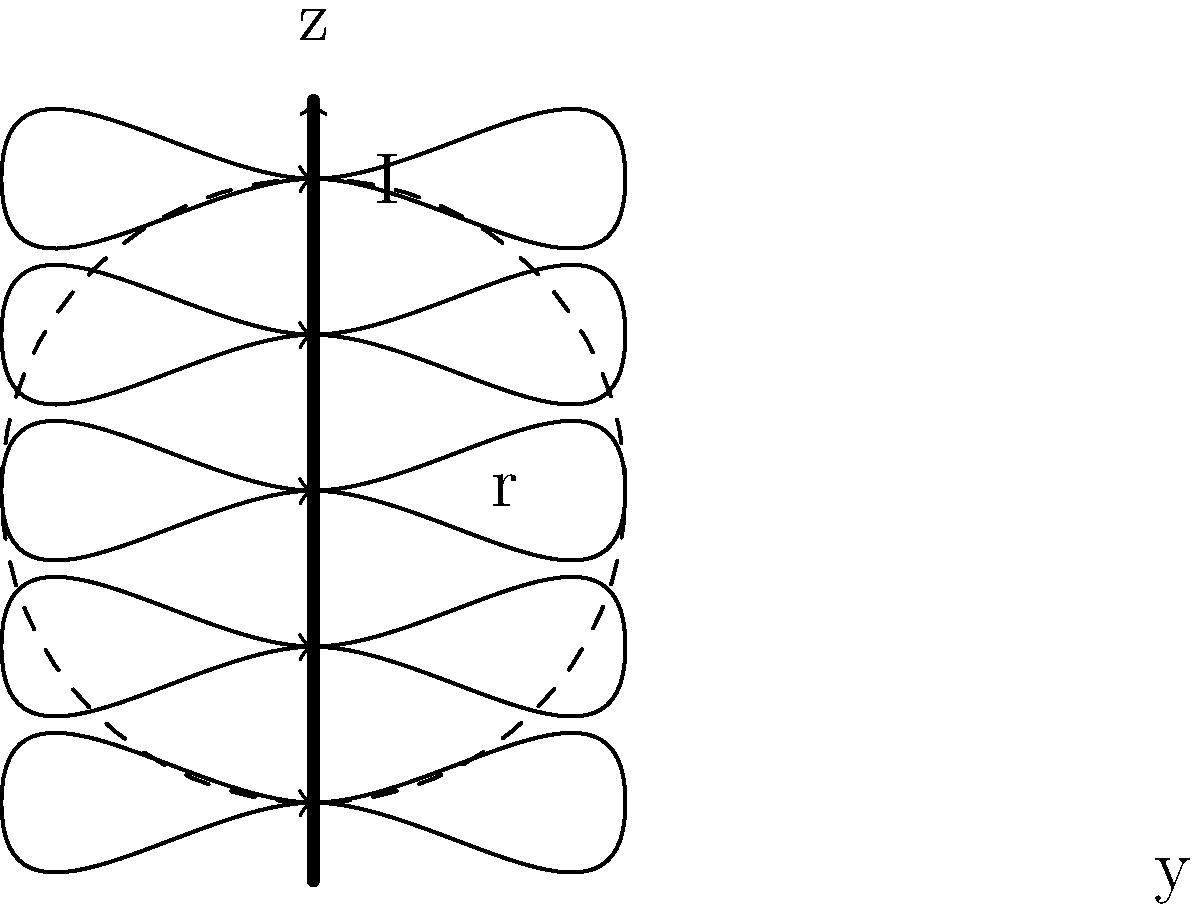As a retired physics professor, consider a long, straight wire carrying a current $I$ in the positive z-direction, as shown in the figure. Using Ampère's law, derive an expression for the magnetic field strength $B$ at a distance $r$ from the wire. Then, calculate the magnetic field strength at a distance of 5 cm from a wire carrying a current of 2 A. Let's approach this step-by-step:

1) Ampère's law states that the line integral of the magnetic field around a closed loop is equal to the product of the permeability of free space and the current enclosed by the loop:

   $$\oint \vec{B} \cdot d\vec{l} = \mu_0 I_{enc}$$

2) For a long, straight wire, the magnetic field lines form concentric circles around the wire. The magnitude of $\vec{B}$ is constant along any circular path centered on the wire.

3) Choose a circular path of radius $r$ around the wire. The line integral becomes:

   $$\oint \vec{B} \cdot d\vec{l} = B(2\pi r)$$

4) The current enclosed is simply $I$. Substituting into Ampère's law:

   $$B(2\pi r) = \mu_0 I$$

5) Solving for $B$:

   $$B = \frac{\mu_0 I}{2\pi r}$$

6) This is the general expression for the magnetic field strength at a distance $r$ from a long, straight wire carrying current $I$.

7) To calculate $B$ at $r = 5$ cm with $I = 2$ A:
   - $\mu_0 = 4\pi \times 10^{-7}$ T·m/A
   - $r = 0.05$ m
   - $I = 2$ A

   $$B = \frac{(4\pi \times 10^{-7})(2)}{2\pi(0.05)} = 8 \times 10^{-6}$$ T

Therefore, the magnetic field strength at a distance of 5 cm from the wire is $8 \times 10^{-6}$ T or 8 µT.
Answer: $8 \times 10^{-6}$ T 